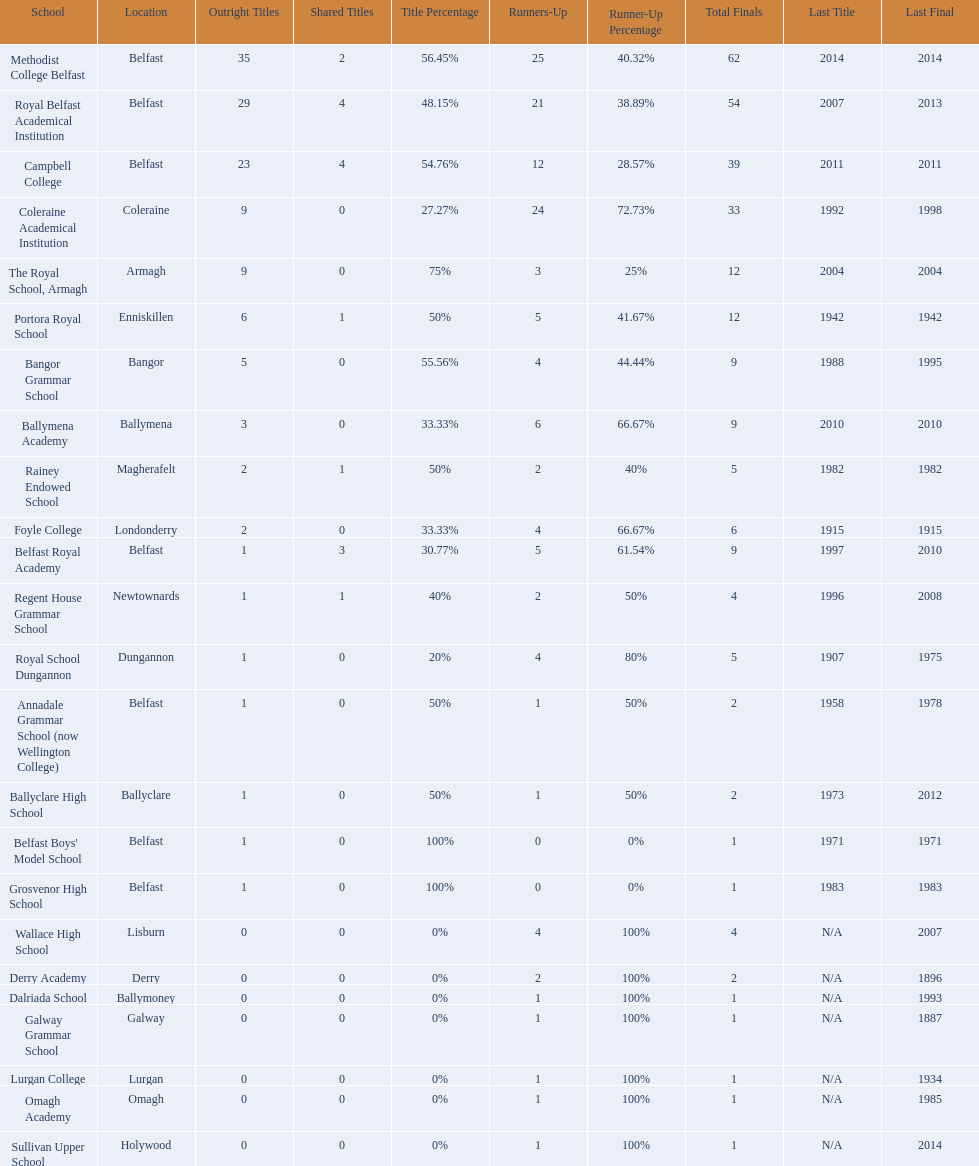Which school has the same number of outright titles as the coleraine academical institution? The Royal School, Armagh. 